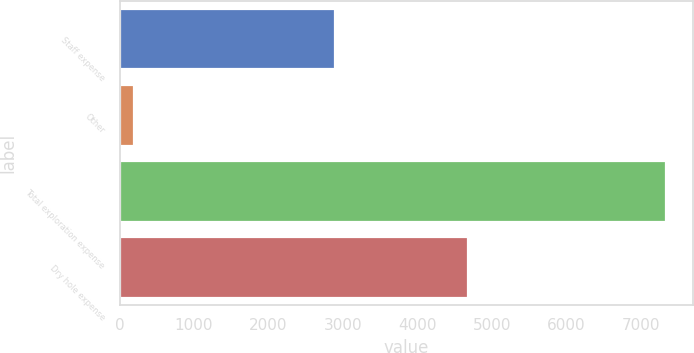Convert chart. <chart><loc_0><loc_0><loc_500><loc_500><bar_chart><fcel>Staff expense<fcel>Other<fcel>Total exploration expense<fcel>Dry hole expense<nl><fcel>2887<fcel>192<fcel>7329<fcel>4676<nl></chart> 